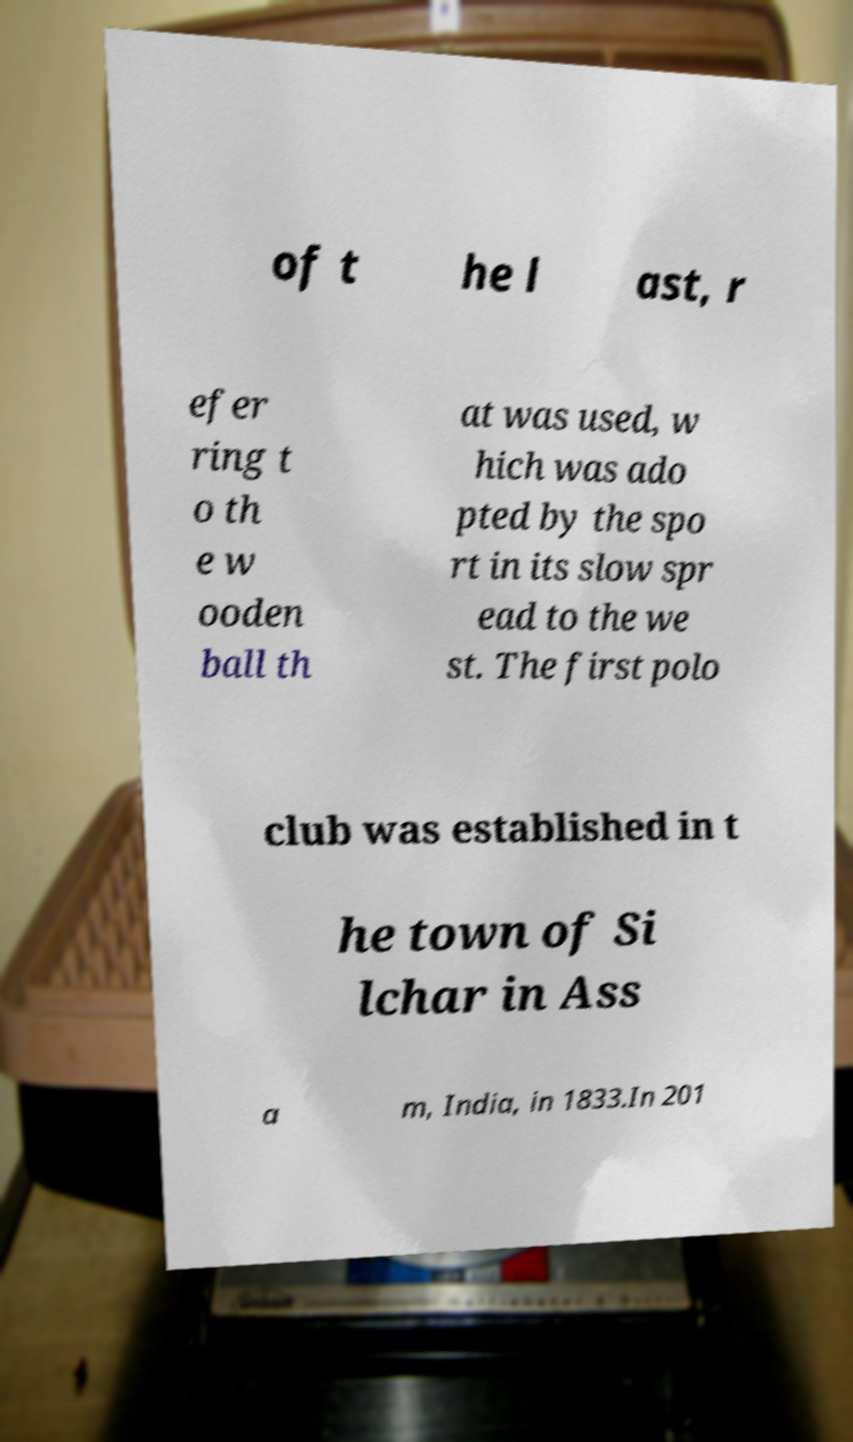I need the written content from this picture converted into text. Can you do that? of t he l ast, r efer ring t o th e w ooden ball th at was used, w hich was ado pted by the spo rt in its slow spr ead to the we st. The first polo club was established in t he town of Si lchar in Ass a m, India, in 1833.In 201 